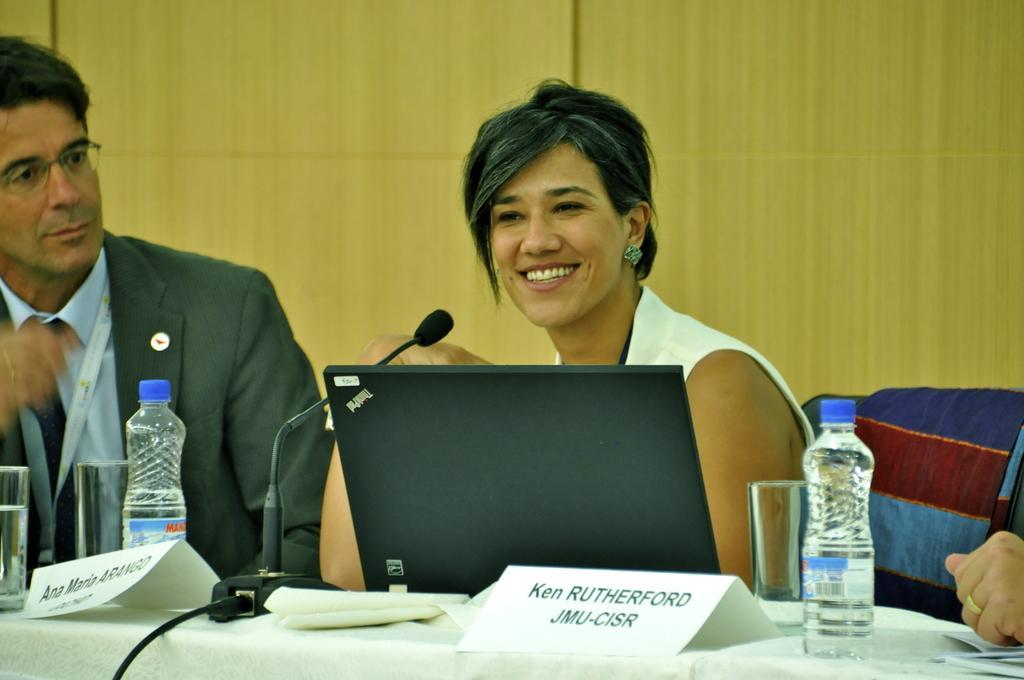Please provide a concise description of this image. Here we can see a man and a woman sitting on the chairs and she is smiling. This is table. On the table there is a cloth, bottles, glasses, and papers. Here we can see a mike. 